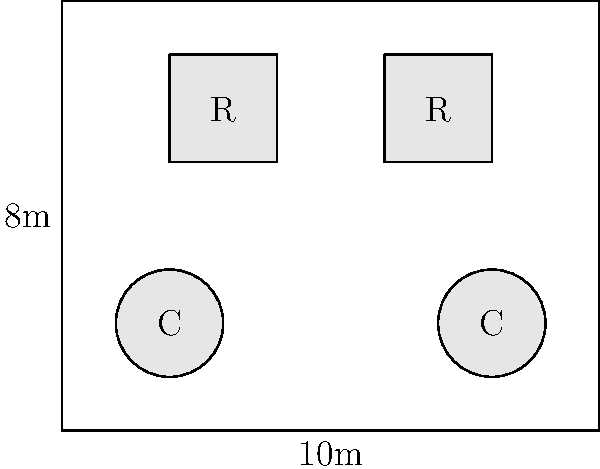In the given floor plan for a dining area, there are two circular tables (C) and two rectangular tables (R). The room measures 10m x 8m. If each circular table can seat 6 people and each rectangular table can seat 8 people, what is the maximum number of guests that can be accommodated while maintaining a minimum space of 1.5m between tables and from tables to walls? To solve this problem, we need to follow these steps:

1. Identify the number and type of tables:
   - 2 circular tables (C)
   - 2 rectangular tables (R)

2. Calculate the seating capacity for each table type:
   - Circular tables: 6 people each
   - Rectangular tables: 8 people each

3. Check if the tables fit in the room with the required spacing:
   - Room size: 10m x 8m
   - Minimum space between tables and from tables to walls: 1.5m
   - The layout in the diagram shows that the tables fit with adequate spacing

4. Calculate the total seating capacity:
   - Circular tables: 2 × 6 = 12 people
   - Rectangular tables: 2 × 8 = 16 people
   - Total: 12 + 16 = 28 people

Therefore, the maximum number of guests that can be accommodated while maintaining the required spacing is 28.
Answer: 28 guests 